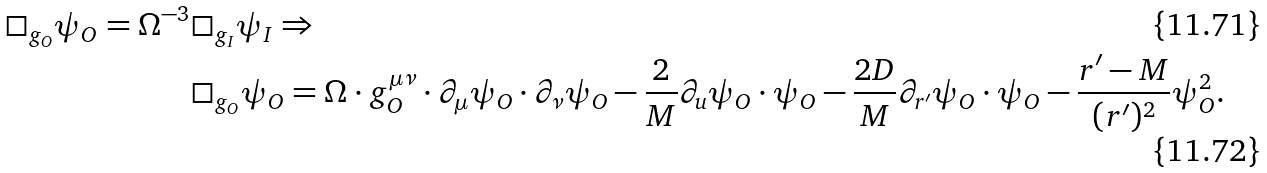<formula> <loc_0><loc_0><loc_500><loc_500>\Box _ { g _ { O } } \psi _ { O } = \Omega ^ { - 3 } & \Box _ { g _ { I } } \psi _ { I } \Rightarrow \\ & \Box _ { g _ { O } } \psi _ { O } = \Omega \cdot g ^ { \mu \nu } _ { O } \cdot \partial _ { \mu } \psi _ { O } \cdot \partial _ { \nu } \psi _ { O } - \frac { 2 } { M } \partial _ { u } \psi _ { O } \cdot \psi _ { O } - \frac { 2 D } { M } \partial _ { r ^ { \prime } } \psi _ { O } \cdot \psi _ { O } - \frac { r ^ { \prime } - M } { ( r ^ { \prime } ) ^ { 2 } } \psi _ { O } ^ { 2 } .</formula> 